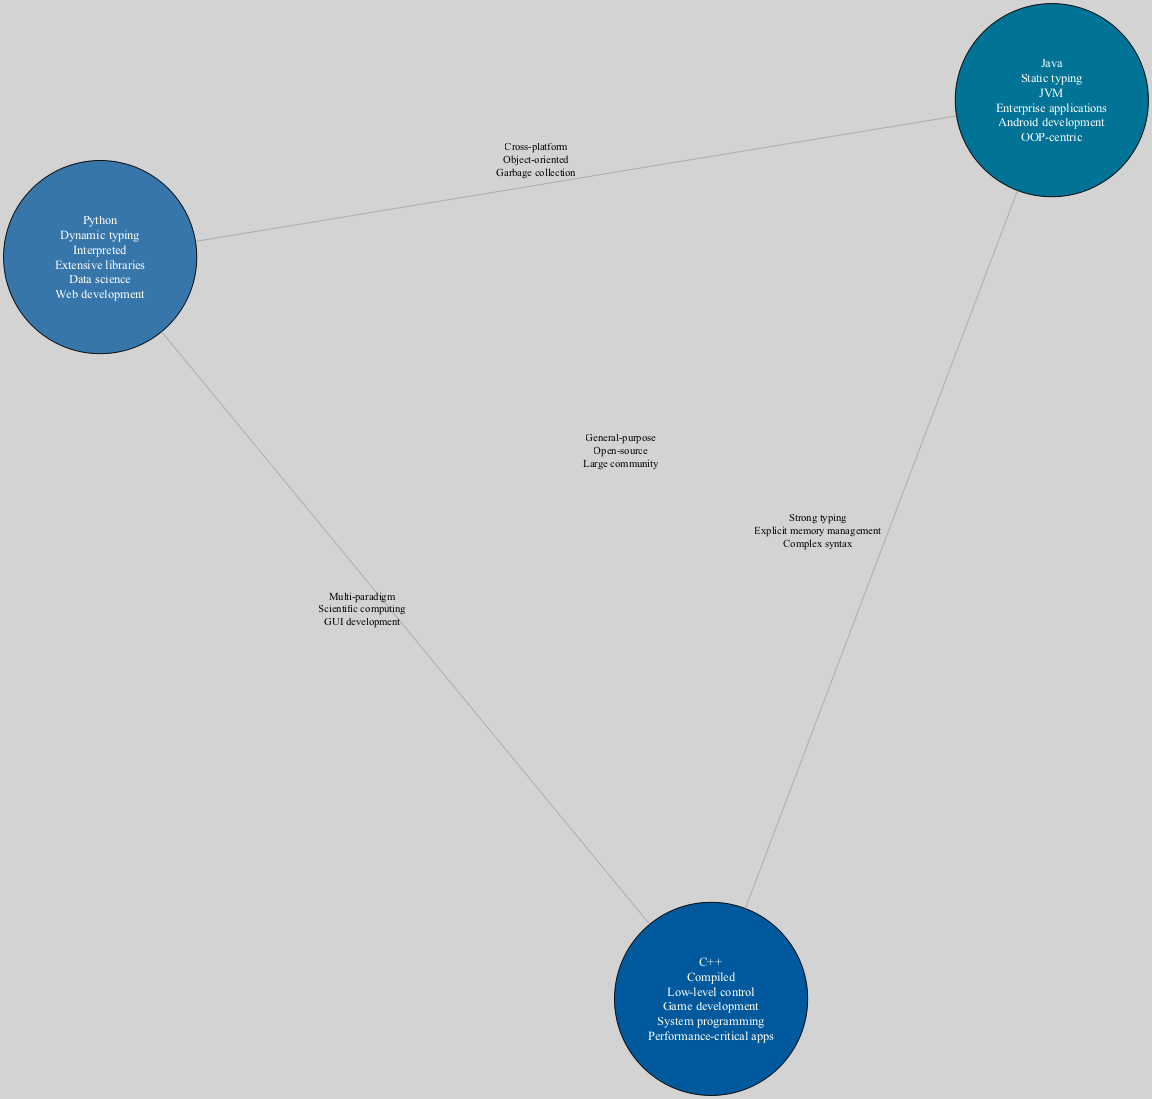What properties differentiate Python from Java? According to the diagram, Python has properties like "Dynamic typing”, "Interpreted", and "Extensive libraries". In contrast, Java has "Static typing", "JVM", and "Enterprise applications". Therefore, the unique properties that differentiate them can be found in their respective circles.
Answer: Dynamic typing, Interpreted, Extensive libraries; Static typing, JVM, Enterprise applications How many unique properties are listed for C++? By inspecting the C++ circle in the diagram, we see that it contains five unique properties: "Compiled", "Low-level control", "Game development", "System programming", and "Performance-critical apps". Thus, the number of unique properties for C++ is five.
Answer: 5 What is a shared property between Python and C++? Looking at the intersection of Python and C++, the diagram indicates the shared properties are "Multi-paradigm", "Scientific computing", and "GUI development". These properties demonstrate common abilities between the two languages.
Answer: Multi-paradigm, Scientific computing, GUI development How many intersections involve all three languages? The diagram specifically shows one intersection when it includes Python, Java, and C++. This intersection is labeled with shared properties such as "General-purpose", "Open-source", and "Large community", indicating common traits among all three languages.
Answer: 1 Which language is associated with Android development? Referencing the Java circle in the diagram, we can see that "Android development" is listed as one of its properties. This directly points to Java as being associated with Android development.
Answer: Java What property represents the shared aspect of Java and C++ related to typing? In the intersection between Java and C++, the diagram notes "Strong typing" as a shared property. This indicates that both programming languages share this characteristic in terms of type enforcement.
Answer: Strong typing What does the central intersection represent? The central intersection of Python, Java, and C++ collectively highlights shared properties among all three. It conveys concepts like "General-purpose", "Open-source", and "Large community", illustrating characteristics common to each language.
Answer: General-purpose, Open-source, Large community What is the unique typology of Python in terms of typing? The diagram indicates that Python is characterized by "Dynamic typing". This is a defining feature of Python that sets it apart from statically typed languages like Java.
Answer: Dynamic typing Identify one performance-related property of C++. The C++ circle shows "Performance-critical apps", which points to its focus on performance optimization, making it suitable for applications where speed is essential.
Answer: Performance-critical apps 